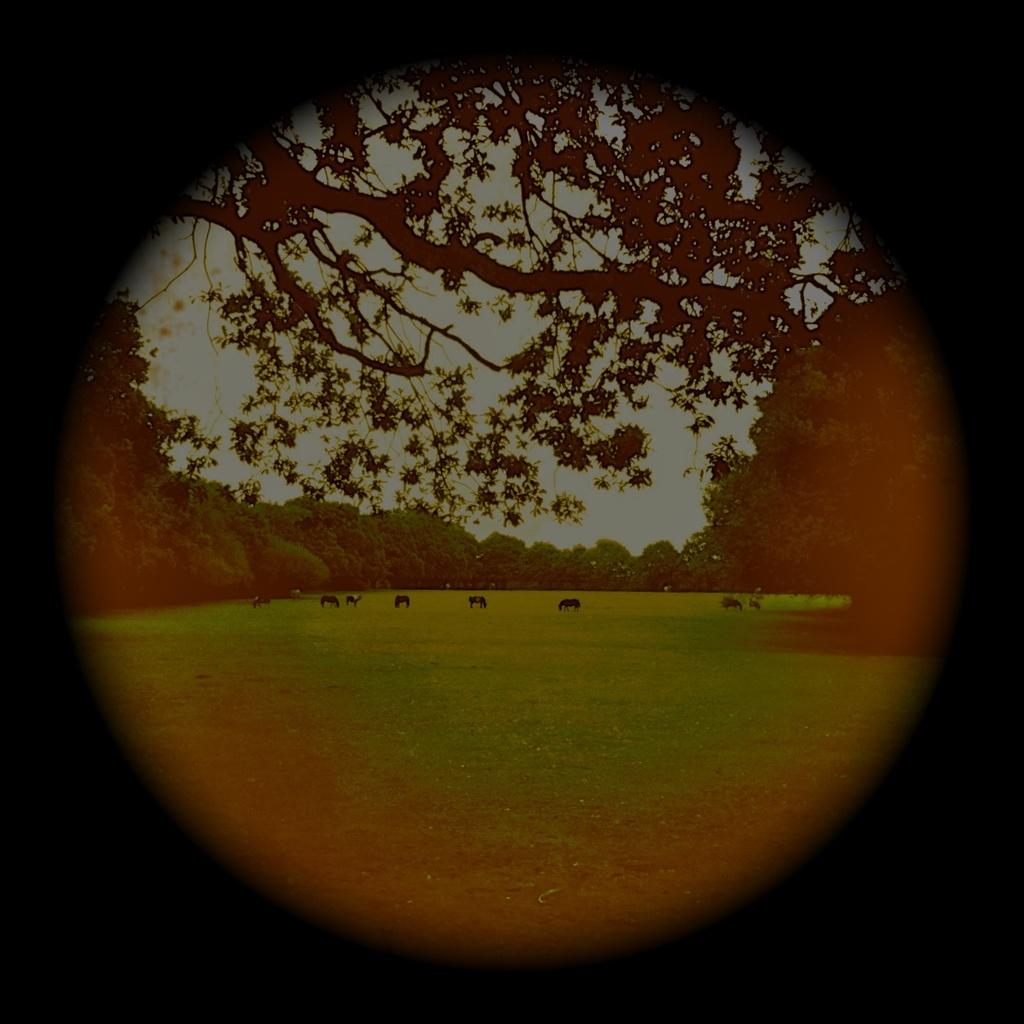What type of vegetation can be seen in the image? There are trees in the image. What is located in the middle of the image? There are animals in the middle of the image. What is visible at the top of the image? The sky is visible at the top of the image. How many eggs are being used by the police in the image? There are no eggs or police present in the image. What type of footwear is the animal wearing in the image? There are no footwear or references to footwear in the image. 